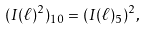<formula> <loc_0><loc_0><loc_500><loc_500>( I ( \ell ) ^ { 2 } ) _ { 1 0 } = ( I ( \ell ) _ { 5 } ) ^ { 2 } ,</formula> 